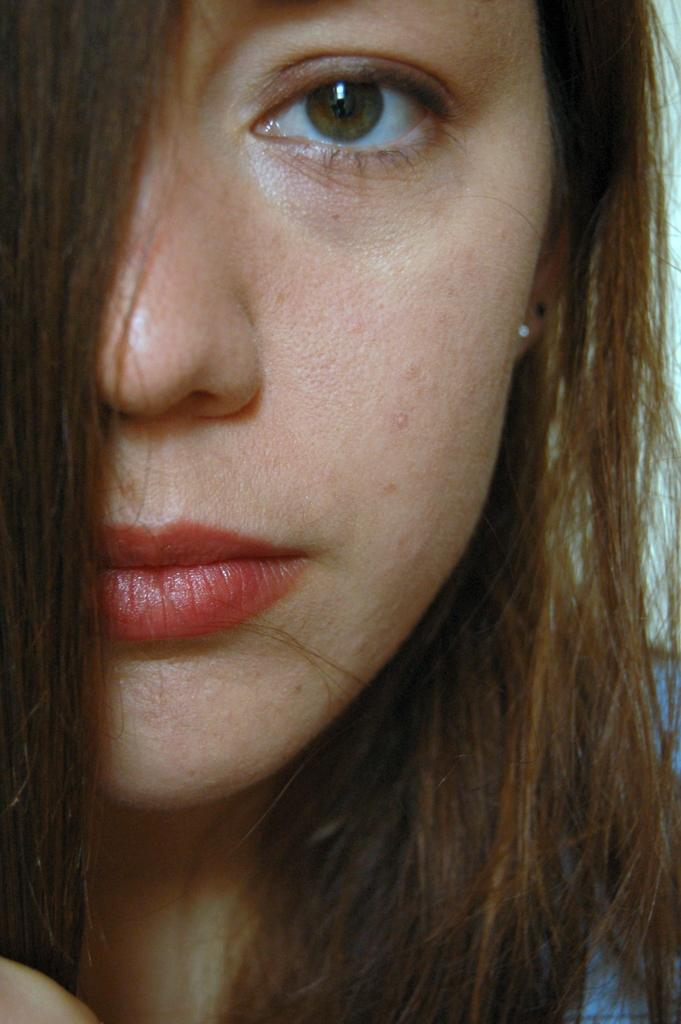What is the focus of the image? The image is a zoomed-in picture of a woman's face. Can you describe the subject of the image in more detail? The subject of the image is a woman's face, which is the main focus of the zoomed-in picture. What type of grain can be seen in the background of the image? There is no grain present in the image, as it is a zoomed-in picture of a woman's face. Is there a box visible in the image? No, there is no box present in the image; it is a close-up of a woman's face. 